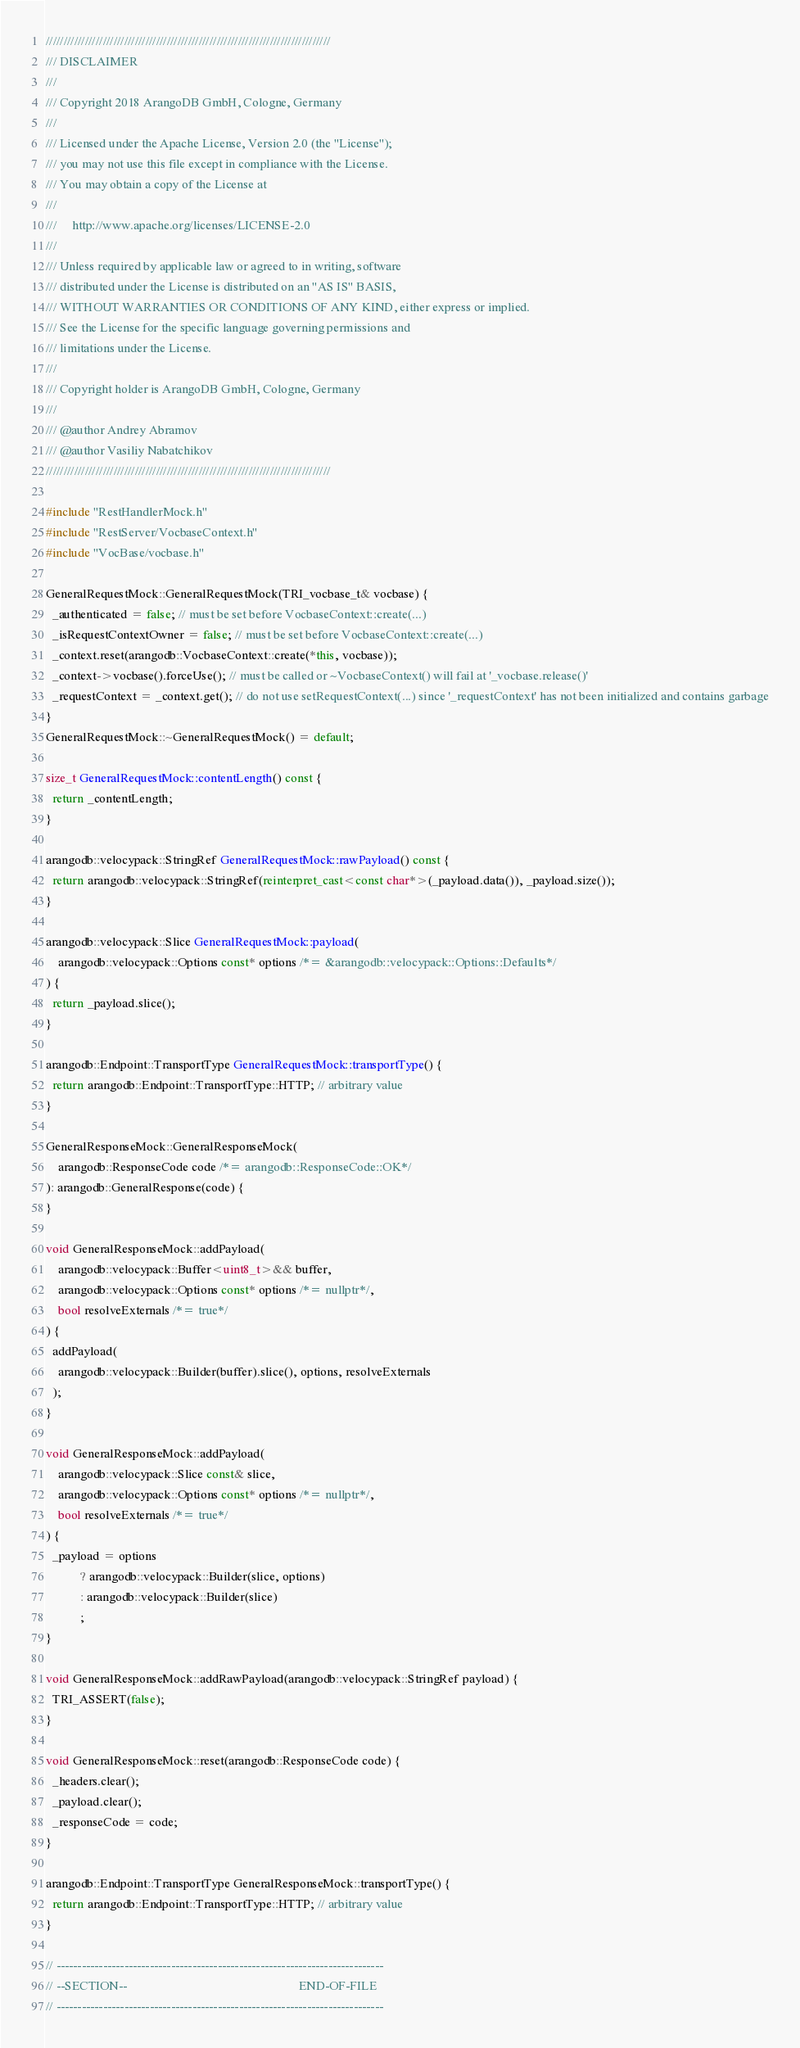<code> <loc_0><loc_0><loc_500><loc_500><_C++_>////////////////////////////////////////////////////////////////////////////////
/// DISCLAIMER
///
/// Copyright 2018 ArangoDB GmbH, Cologne, Germany
///
/// Licensed under the Apache License, Version 2.0 (the "License");
/// you may not use this file except in compliance with the License.
/// You may obtain a copy of the License at
///
///     http://www.apache.org/licenses/LICENSE-2.0
///
/// Unless required by applicable law or agreed to in writing, software
/// distributed under the License is distributed on an "AS IS" BASIS,
/// WITHOUT WARRANTIES OR CONDITIONS OF ANY KIND, either express or implied.
/// See the License for the specific language governing permissions and
/// limitations under the License.
///
/// Copyright holder is ArangoDB GmbH, Cologne, Germany
///
/// @author Andrey Abramov
/// @author Vasiliy Nabatchikov
////////////////////////////////////////////////////////////////////////////////

#include "RestHandlerMock.h"
#include "RestServer/VocbaseContext.h"
#include "VocBase/vocbase.h"

GeneralRequestMock::GeneralRequestMock(TRI_vocbase_t& vocbase) {
  _authenticated = false; // must be set before VocbaseContext::create(...)
  _isRequestContextOwner = false; // must be set before VocbaseContext::create(...)
  _context.reset(arangodb::VocbaseContext::create(*this, vocbase));
  _context->vocbase().forceUse(); // must be called or ~VocbaseContext() will fail at '_vocbase.release()'
  _requestContext = _context.get(); // do not use setRequestContext(...) since '_requestContext' has not been initialized and contains garbage
}
GeneralRequestMock::~GeneralRequestMock() = default;

size_t GeneralRequestMock::contentLength() const {
  return _contentLength;
}

arangodb::velocypack::StringRef GeneralRequestMock::rawPayload() const {
  return arangodb::velocypack::StringRef(reinterpret_cast<const char*>(_payload.data()), _payload.size());
}

arangodb::velocypack::Slice GeneralRequestMock::payload(
    arangodb::velocypack::Options const* options /*= &arangodb::velocypack::Options::Defaults*/
) {
  return _payload.slice();
}

arangodb::Endpoint::TransportType GeneralRequestMock::transportType() {
  return arangodb::Endpoint::TransportType::HTTP; // arbitrary value
}

GeneralResponseMock::GeneralResponseMock(
    arangodb::ResponseCode code /*= arangodb::ResponseCode::OK*/
): arangodb::GeneralResponse(code) {
}

void GeneralResponseMock::addPayload(
    arangodb::velocypack::Buffer<uint8_t>&& buffer,
    arangodb::velocypack::Options const* options /*= nullptr*/,
    bool resolveExternals /*= true*/
) {
  addPayload(
    arangodb::velocypack::Builder(buffer).slice(), options, resolveExternals
  );
}

void GeneralResponseMock::addPayload(
    arangodb::velocypack::Slice const& slice,
    arangodb::velocypack::Options const* options /*= nullptr*/,
    bool resolveExternals /*= true*/
) {
  _payload = options
           ? arangodb::velocypack::Builder(slice, options)
           : arangodb::velocypack::Builder(slice)
           ;
}

void GeneralResponseMock::addRawPayload(arangodb::velocypack::StringRef payload) {
  TRI_ASSERT(false);
}

void GeneralResponseMock::reset(arangodb::ResponseCode code) {
  _headers.clear();
  _payload.clear();
  _responseCode = code;
}

arangodb::Endpoint::TransportType GeneralResponseMock::transportType() {
  return arangodb::Endpoint::TransportType::HTTP; // arbitrary value
}

// -----------------------------------------------------------------------------
// --SECTION--                                                       END-OF-FILE
// -----------------------------------------------------------------------------
</code> 